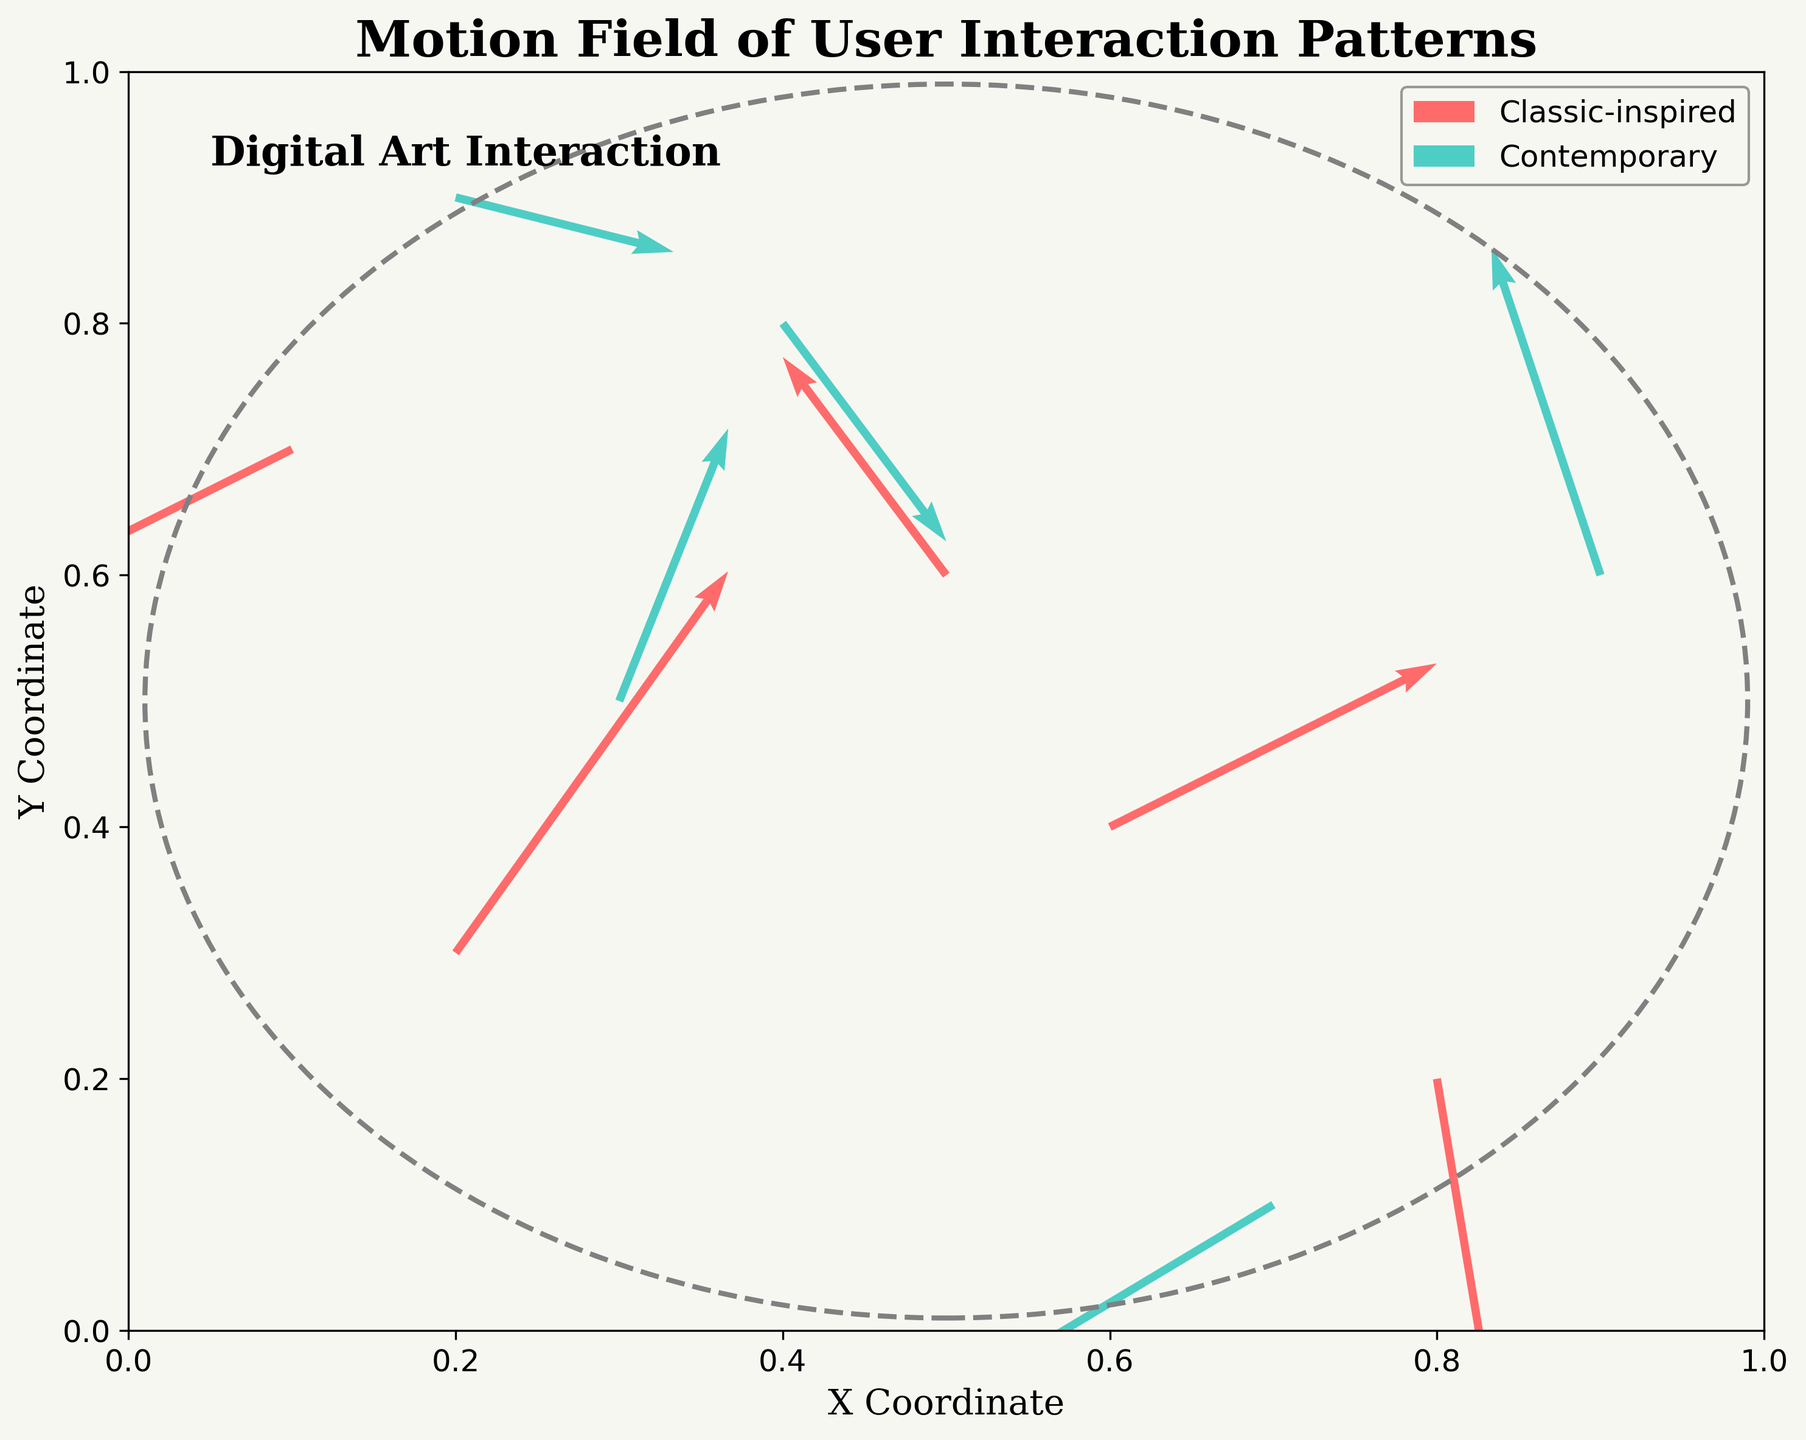What is the title of the plot? The title of the plot is usually displayed at the top of the figure. Here, it reads "Motion Field of User Interaction Patterns".
Answer: Motion Field of User Interaction Patterns What are the colors used to represent the different design types? The classic-inspired design is represented using a reddish color, and the contemporary design is represented using a cyan-greenish color.
Answer: Red and cyan-green How many interaction patterns are plotted for each design type? By counting the number of arrows for each design type, we see there are 5 classic-inspired and 5 contemporary interaction patterns.
Answer: 5 for each What is the scale factor used for the vectors? The scale factor for the vectors is specified in the plot's legend or may be inferred from titles or other descriptions. Here, it's provided as a setting in the description: "scale=3".
Answer: 3 Which design type has an interaction pattern with the most significant positive Y-velocity component? By comparing the vectors representing Y-velocity components (v values), the most significant positive Y-velocity component is 0.7 from a classic-inspired design.
Answer: Classic-inspired What is the average length of the interaction patterns (vector magnitudes) for contemporary designs? Calculate the magnitude of each vector for contemporary designs using the formula sqrt(u^2 + v^2): sqrt(0.2^2 + 0.5^2), sqrt(-0.5^2 + -0.3^2), sqrt(0.3^2 + -0.4^2), sqrt(-0.2^2 + 0.6^2), sqrt(0.4^2 + -0.1^2). Then sum these magnitudes and divide by 5.
Answer: Approximately 0.51 What is the range of X-coordinates for contemporary designs? The X-coordinates for contemporary designs are 0.3, 0.7, 0.4, 0.9, and 0.2. The range is max(X) - min(X), which is 0.9 - 0.2.
Answer: 0.7 Which design type shows more diverse interaction directions? By observing the overall directions of the arrows, contemporary designs have interactions going up, down, left, right, and combinations, indicating more diversity compared to classic designs.
Answer: Contemporary What percentage of classic-inspired designs have a negative X-velocity component? There are 5 classic-inspired designs out of which 2 have negative X-velocities (-0.3 and -0.4), making it (2/5) * 100%.
Answer: 40% Which single vector has the largest magnitude among all interaction patterns? Calculate the magnitude for all vectors and compare: sqrt(0.5^2 + 0.7^2) ≈ 0.86 is the highest magnitude among all.
Answer: Classic-inspired at (0.2, 0.3) 